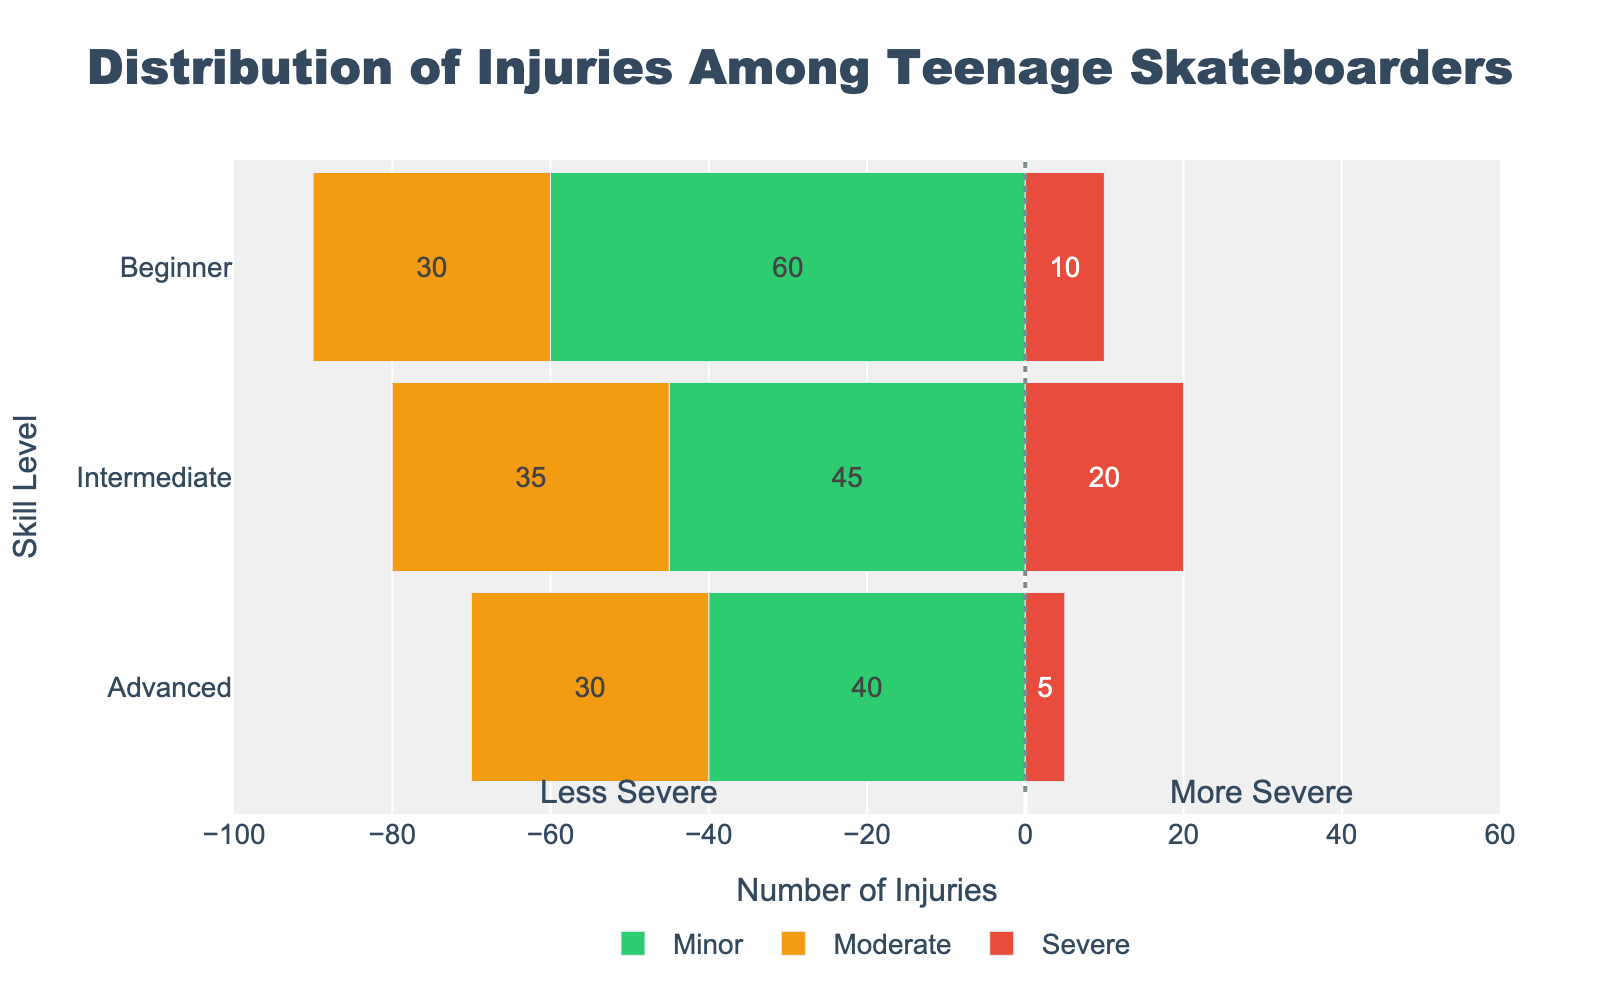What is the total number of injuries for beginners? Add the counts for minor, moderate, and severe injuries for beginners: 60 (minor) + 30 (moderate) + 10 (severe) = 100
Answer: 100 Which skill level has the highest number of minor injuries? Compare the counts of minor injuries for all skill levels: Beginners have 60, Intermediates have 45, and Advanced have 40. Beginners have the highest.
Answer: Beginners What is the difference in the number of severe injuries between intermediates and advanced skaters? Subtract the number of severe injuries for advanced skaters from intermediates: 20 (intermediate) - 5 (advanced) = 15
Answer: 15 How do the moderate injuries for beginners and intermediates compare? Compare the counts for moderate injuries: Beginners have 30 and Intermediates have 35, so intermediates have more moderate injuries.
Answer: Intermediates have more What percentage of injuries among advanced skateboarders are severe? Calculate the percentage: The total number of injuries for advanced skaters is 40 (minor) + 30 (moderate) + 5 (severe) = 75. The severe injuries are 5. So, (5/75) * 100 ≈ 6.67%
Answer: 6.67% Which injury type has the second highest count among intermediate skateboarders? List the counts for intermediate skaters: Minor (45), Moderate (35), Severe (20). The second highest is moderate with 35 injuries.
Answer: Moderate What is the ratio of minor to severe injuries for beginners? Calculate the ratio: Minor injuries for beginners are 60 and severe injuries are 10. So, 60/10 = 6
Answer: 6:1 How many more severe injuries do beginners have compared to advanced skaters? Subtract the number of severe injuries for advanced skaters from beginners: 10 (beginners) - 5 (advanced) = 5
Answer: 5 Are moderate injuries more common than severe injuries across all skill levels? Add up all moderate and severe injuries: Moderate: 30 (beginners) + 35 (intermediates) + 30 (advanced) = 95. Severe: 10 (beginners) + 20 (intermediates) + 5 (advanced) = 35. Moderate injuries are more common.
Answer: Yes What is the combined total of minor and moderate injuries for intermediates? Add the counts for minor and moderate injuries for intermediates: 45 (minor) + 35 (moderate) = 80
Answer: 80 